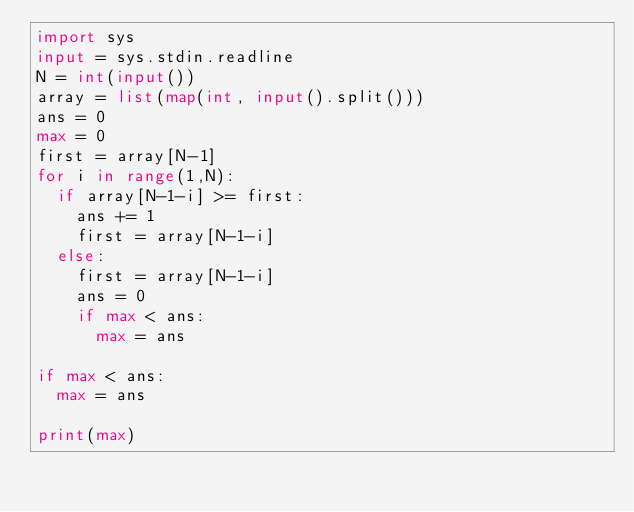<code> <loc_0><loc_0><loc_500><loc_500><_Python_>import sys
input = sys.stdin.readline
N = int(input())
array = list(map(int, input().split()))
ans = 0
max = 0
first = array[N-1]
for i in range(1,N):
	if array[N-1-i] >= first:
		ans += 1
		first = array[N-1-i]
	else:
		first = array[N-1-i]
		ans = 0
		if max < ans:
			max = ans

if max < ans:
	max = ans

print(max)
</code> 